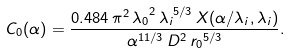Convert formula to latex. <formula><loc_0><loc_0><loc_500><loc_500>C _ { 0 } ( \alpha ) = \frac { 0 . 4 8 4 \, \pi ^ { 2 } \, { \lambda _ { 0 } } ^ { 2 } \, { \lambda _ { i } } ^ { 5 / 3 } \, X ( \alpha / \lambda _ { i } , \lambda _ { i } ) } { \alpha ^ { 1 1 / 3 } \, D ^ { 2 } \, { r _ { 0 } } ^ { 5 / 3 } } .</formula> 